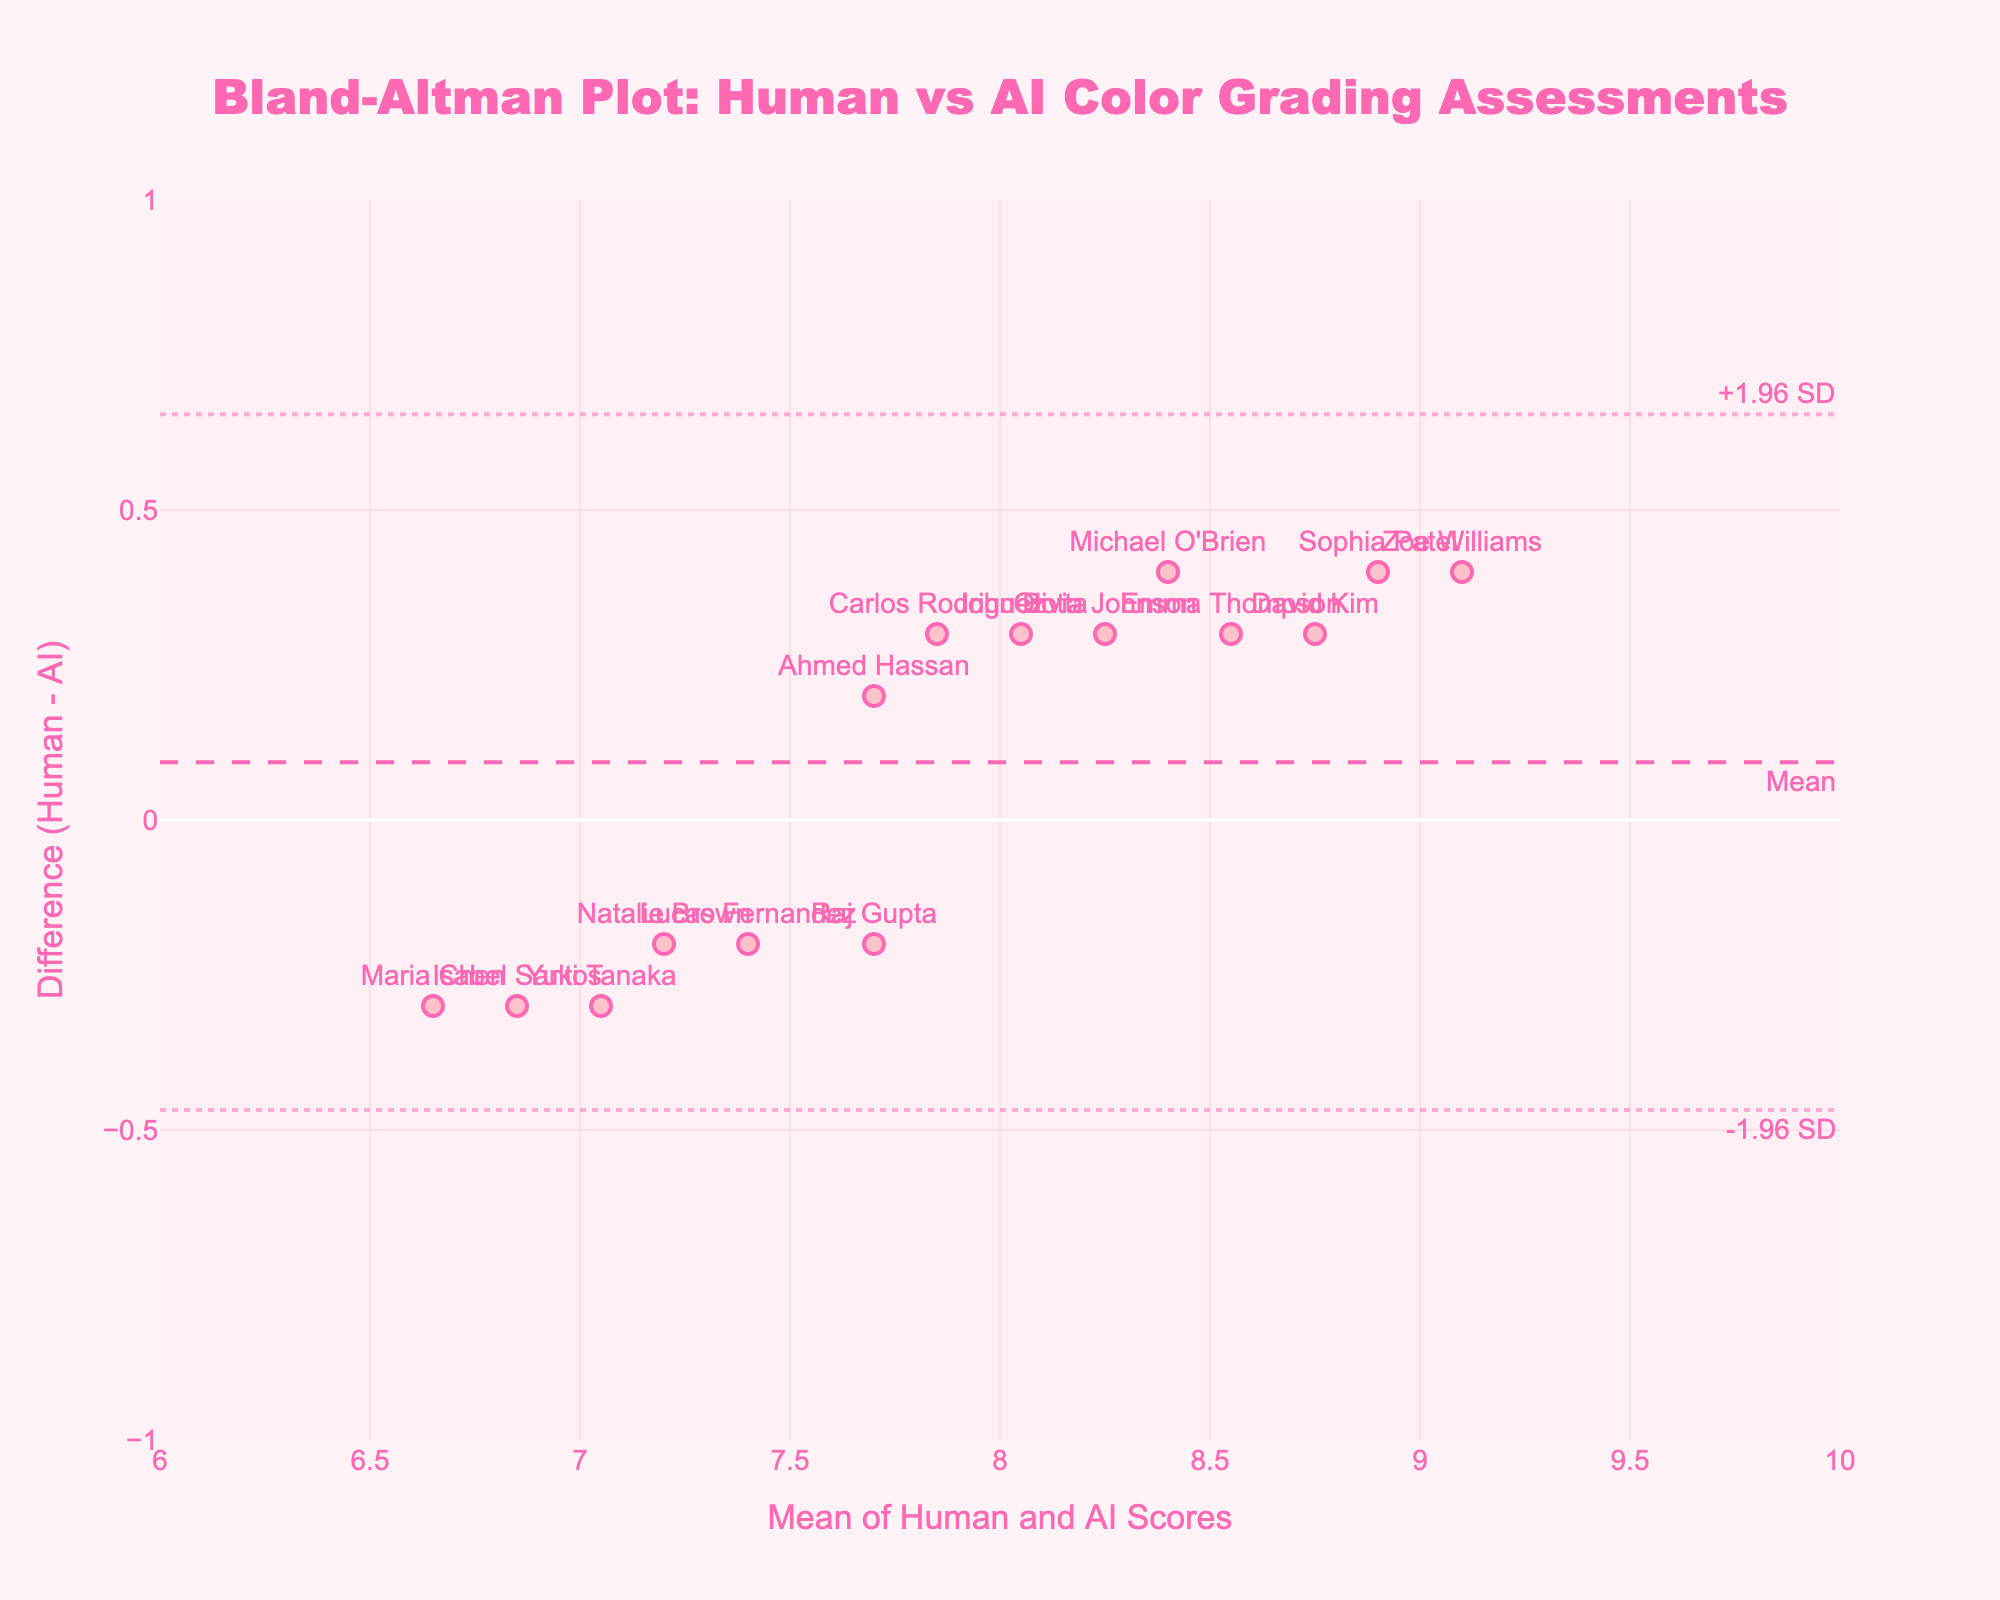What is the title of the plot? The title is displayed at the top of the figure in a larger and bold font, it reads: "Bland-Altman Plot: Human vs AI Color Grading Assessments".
Answer: Bland-Altman Plot: Human vs AI Color Grading Assessments What is the x-axis labeled as? The x-axis label can be seen below the axis, it is: "Mean of Human and AI Scores".
Answer: Mean of Human and AI Scores How many color grading assessments are plotted? Each marker on the plot represents a color grading assessment done by both a human and AI. Counting the markers gives us the total number of assessments.
Answer: 15 What is the mean difference between the human and AI scores? The mean difference is represented by a dashed horizontal line and is labeled on the plot as "Mean". Based on the figure, this line is located at one specific point on the y-axis.
Answer: Approximately 0.1 What are the upper and lower limits of agreement? The upper and lower limits of agreement are depicted by dotted lines, usually labeled with annotations such as "+1.96 SD" for the upper limit and "-1.96 SD" for the lower limit. Observing their positions on the y-axis provides the values.
Answer: Upper: Approximately 0.43, Lower: -0.23 Which colorist has the largest positive difference between human and AI scores? To determine this, look for the marker that is farthest above the zero line on the y-axis and check the corresponding colorist label next to it.
Answer: Zoe Williams Which data points have a mean score of about 8.5? Data points close to the mean value of 8.5 on the x-axis should be identified, then check the associated labels to find the names of the colorists.
Answer: Olivia Johnson, Emma Thompson, and Michael O'Brien What is the difference in scores for the colorist Sophia Patel? Locate Sophia Patel’s marker on the plot; her difference score is the y-coordinate of her marker.
Answer: 0.4 Are there any colorists where AI rated higher than the human? A positive difference on the y-axis indicates that the human rated higher than the AI, so identify markers below the zero line to find cases where AI rated higher.
Answer: Yes, Maria Chen, Yuki Tanaka, Isabel Santos How does Lucas Fernandez's score compare to John Botta's? Compare their positions along the y-axis to see if Lucas Fernandez's marker is above, below, or at the same level as John Botta's marker.
Answer: Lucas is slightly higher than John 